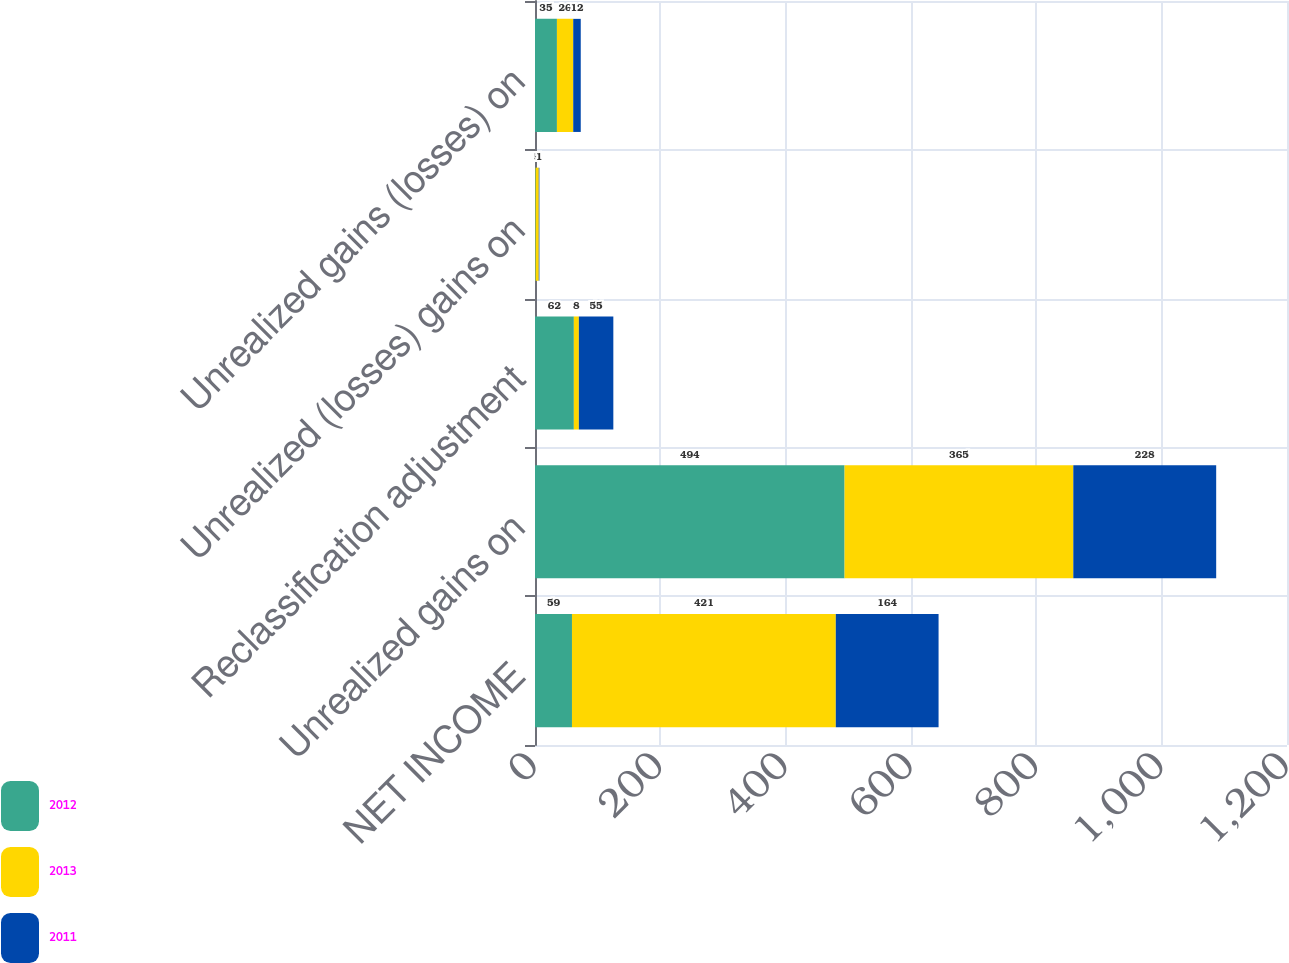Convert chart to OTSL. <chart><loc_0><loc_0><loc_500><loc_500><stacked_bar_chart><ecel><fcel>NET INCOME<fcel>Unrealized gains on<fcel>Reclassification adjustment<fcel>Unrealized (losses) gains on<fcel>Unrealized gains (losses) on<nl><fcel>2012<fcel>59<fcel>494<fcel>62<fcel>1<fcel>35<nl><fcel>2013<fcel>421<fcel>365<fcel>8<fcel>5<fcel>26<nl><fcel>2011<fcel>164<fcel>228<fcel>55<fcel>1<fcel>12<nl></chart> 